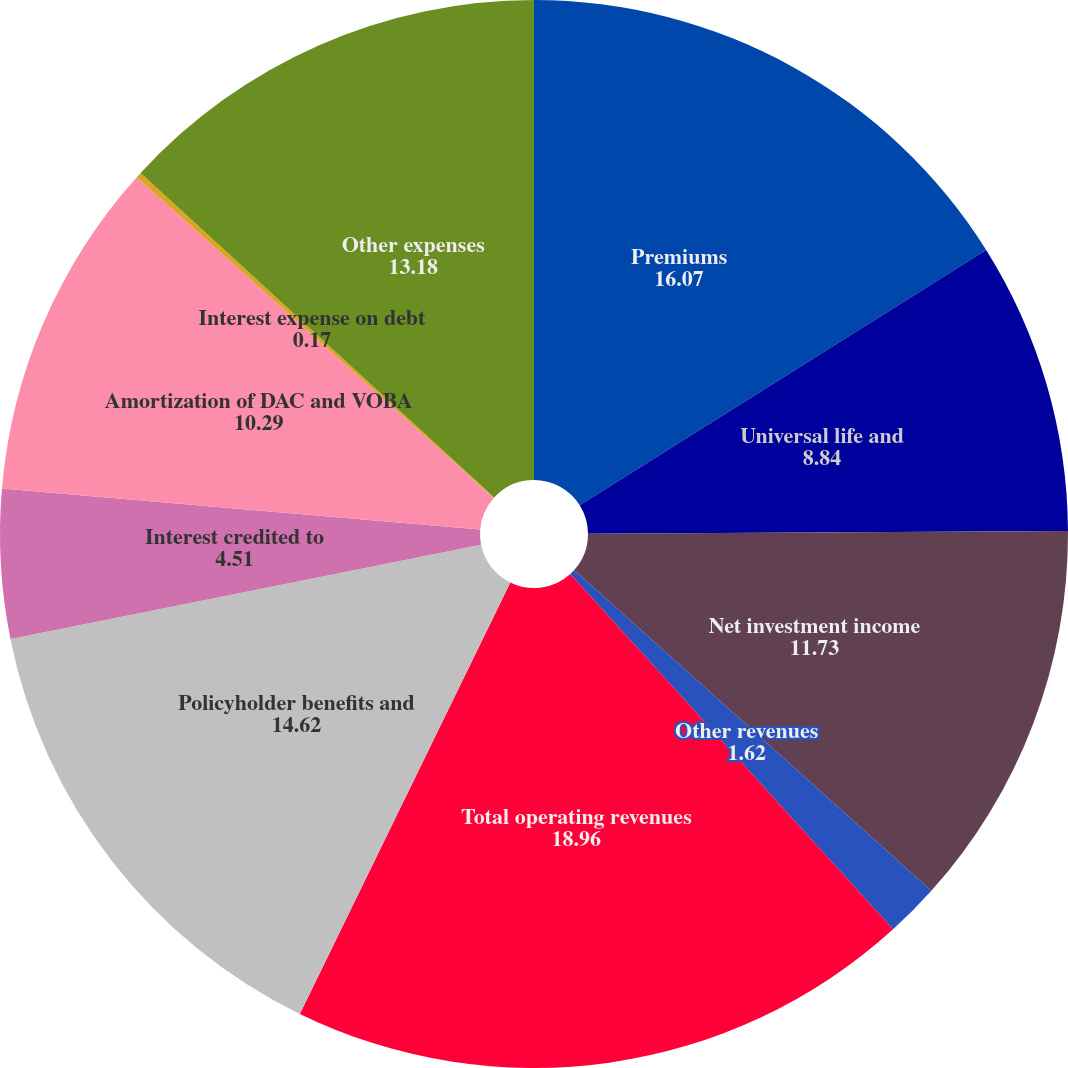Convert chart. <chart><loc_0><loc_0><loc_500><loc_500><pie_chart><fcel>Premiums<fcel>Universal life and<fcel>Net investment income<fcel>Other revenues<fcel>Total operating revenues<fcel>Policyholder benefits and<fcel>Interest credited to<fcel>Amortization of DAC and VOBA<fcel>Interest expense on debt<fcel>Other expenses<nl><fcel>16.07%<fcel>8.84%<fcel>11.73%<fcel>1.62%<fcel>18.96%<fcel>14.62%<fcel>4.51%<fcel>10.29%<fcel>0.17%<fcel>13.18%<nl></chart> 